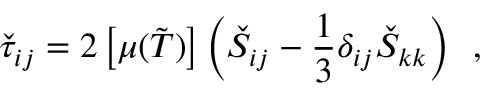Convert formula to latex. <formula><loc_0><loc_0><loc_500><loc_500>\check { \tau } _ { i j } = 2 \left [ \mu ( \tilde { T } ) \right ] \left ( \check { S } _ { i j } - \frac { 1 } { 3 } \delta _ { i j } \check { S } _ { k k } \right ) \, ,</formula> 